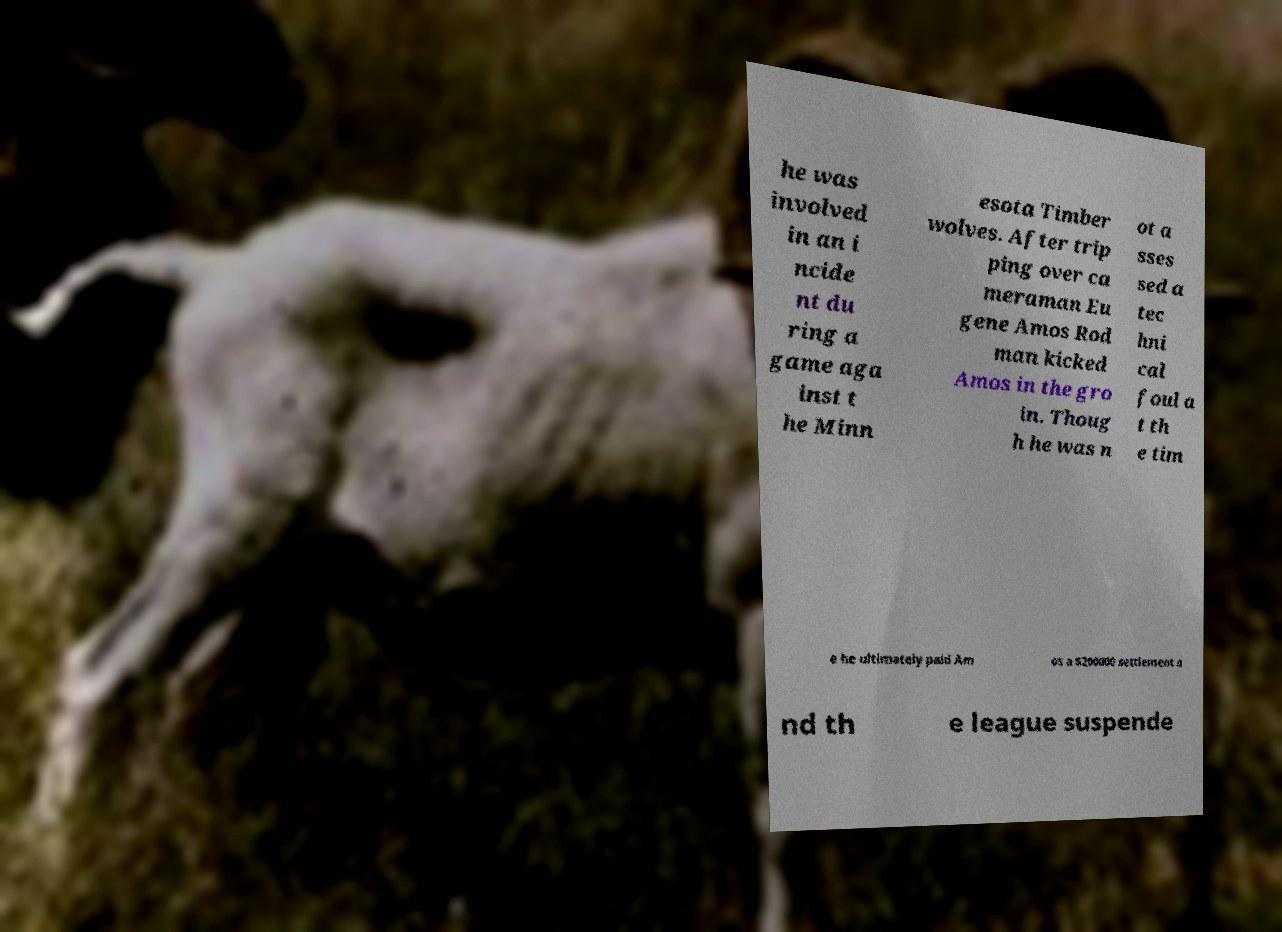Could you extract and type out the text from this image? he was involved in an i ncide nt du ring a game aga inst t he Minn esota Timber wolves. After trip ping over ca meraman Eu gene Amos Rod man kicked Amos in the gro in. Thoug h he was n ot a sses sed a tec hni cal foul a t th e tim e he ultimately paid Am os a $200000 settlement a nd th e league suspende 